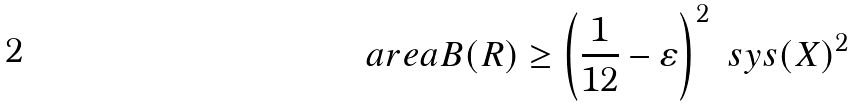Convert formula to latex. <formula><loc_0><loc_0><loc_500><loc_500>\ a r e a B ( R ) \geq \left ( \frac { 1 } { 1 2 } - \varepsilon \right ) ^ { 2 } \ s y s ( X ) ^ { 2 }</formula> 